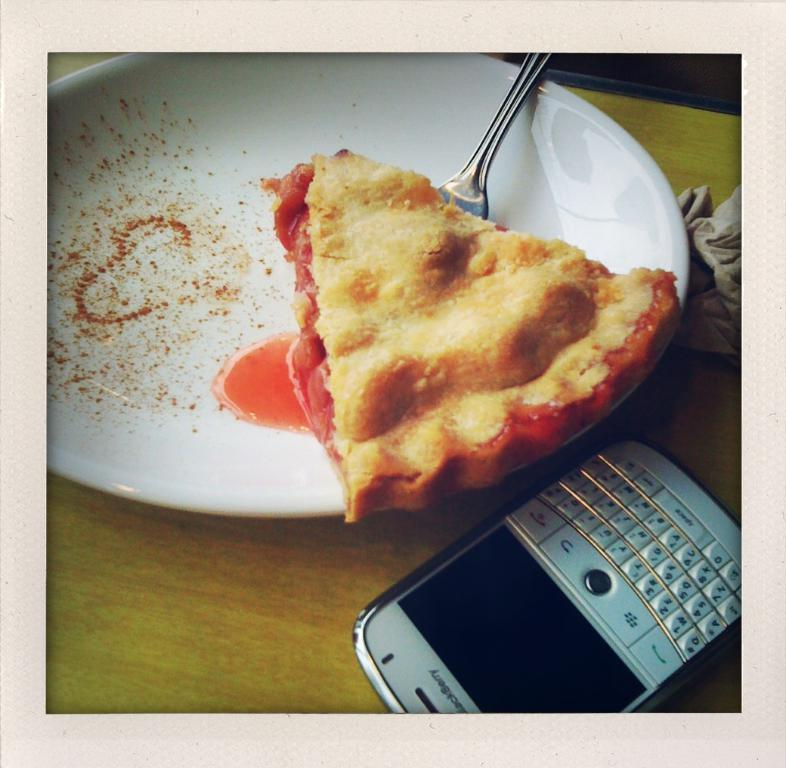What is on the plate in the image? There is food on a plate in the image. What utensil is present in the image? There is a spoon in the image. Where is the phone located in the image? The phone is on a wooden table in the image. What type of beef is being served on the plate in the image? There is no beef present in the image; it only mentions that there is food on the plate. How does the fowl say good-bye in the image? There is no fowl present in the image, and therefore it cannot say good-bye. 